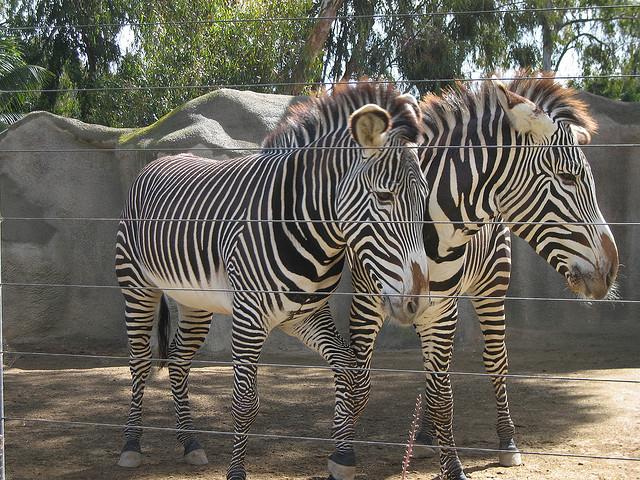How many zebras?
Concise answer only. 2. Are the zebra roaming free?
Write a very short answer. No. How many wires are holding the zebras in?
Concise answer only. 6. 